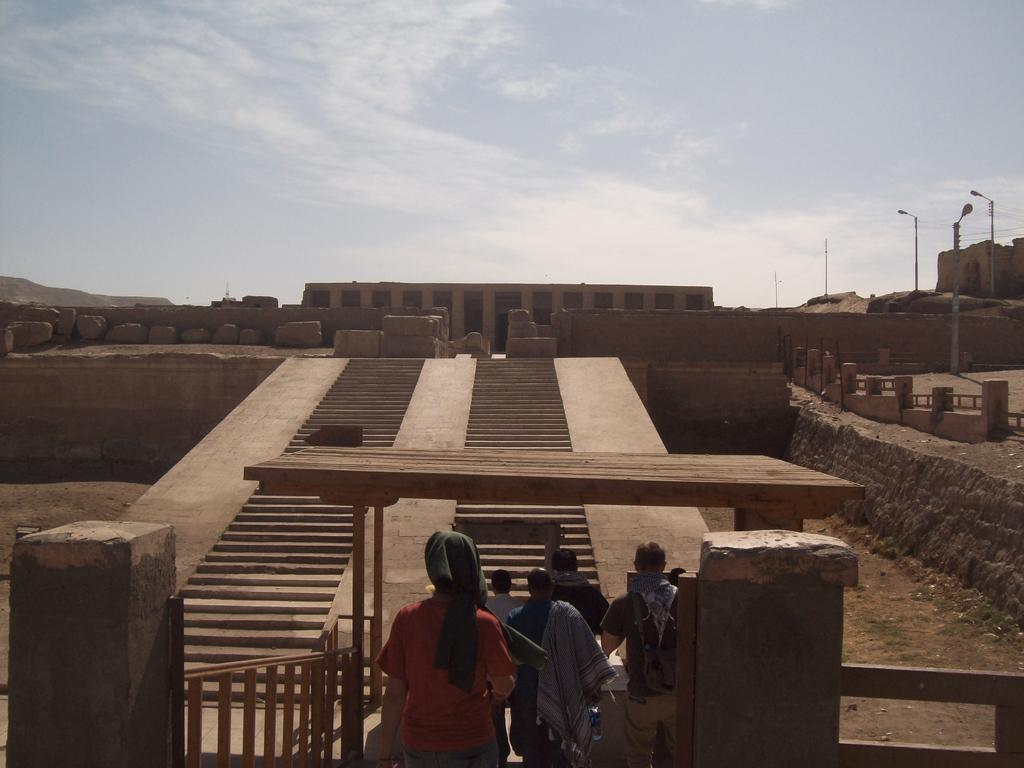What can be seen in the background of the image? There is a sky and a fort visible in the background of the image. Who or what is present in the image? There are people in the image. What type of natural features are present in the image? There are rocks in the image. What type of man-made objects are present in the image? There are wooden objects in the image. Can you tell me how many people are sleeping in the image? There is no indication of anyone sleeping in the image. What type of battle is taking place in the image? There is no battle present in the image; it features a sky, a fort, people, rocks, and wooden objects. 